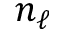Convert formula to latex. <formula><loc_0><loc_0><loc_500><loc_500>n _ { \ell }</formula> 